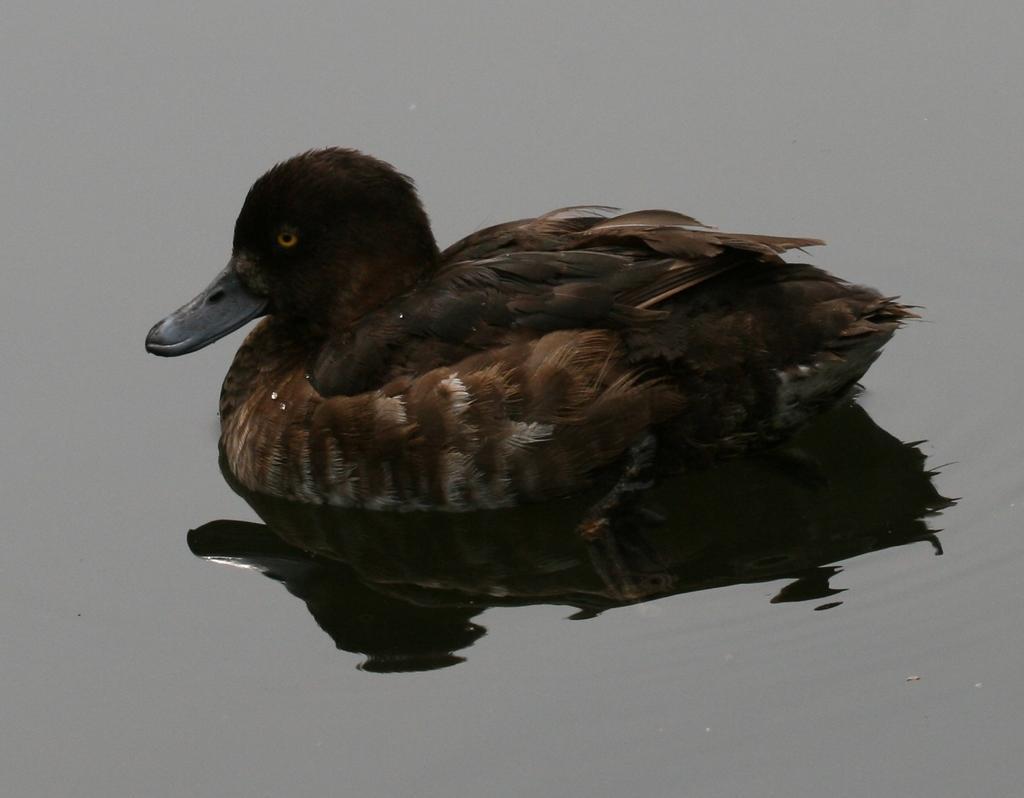Could you give a brief overview of what you see in this image? In this picture there is a black duck on the water. 